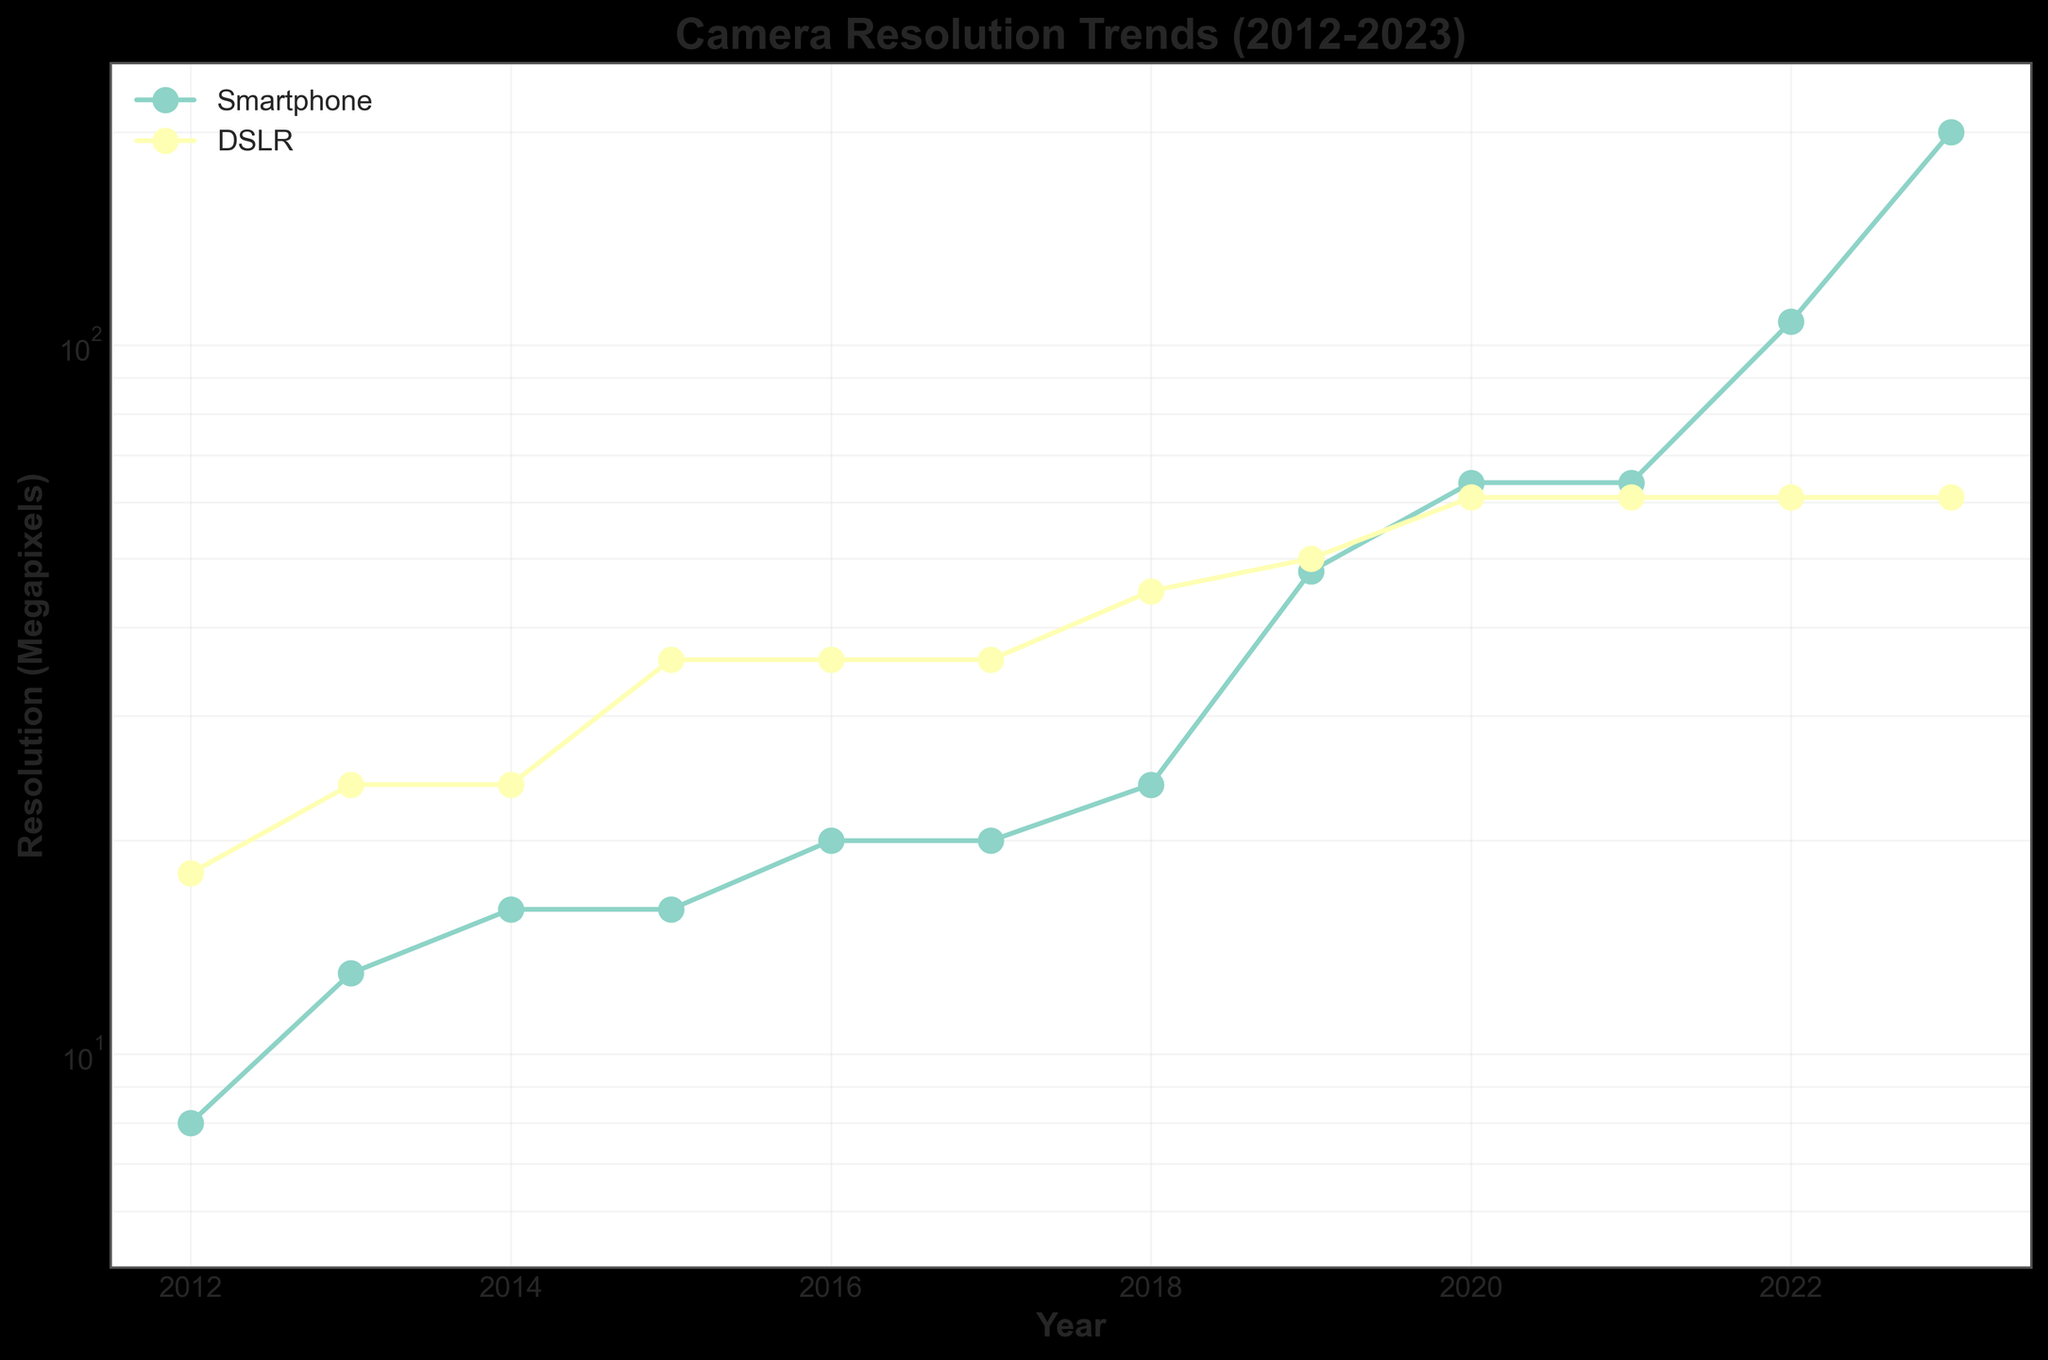What is the title of the figure? The title is displayed at the top of the figure in bold font.
Answer: Camera Resolution Trends (2012-2023) What are the devices compared in the figure? The legend in the upper left corner identifies the two device types with different labels and colors.
Answer: Smartphones and DSLRs How does the resolution of smartphones change from 2012 to 2023? Trace the points for the Smartphone line starting from 2012 to 2023, noting down the corresponding resolutions.
Answer: From 8 Megapixels to 200 Megapixels Which year shows the greatest increase in smartphone resolution? Look for the year where the gap between two consecutive points in the Smartphone line is the largest.
Answer: 2019 to 2020 What is the maximum resolution achieved by DSLRs over the years shown? Find the highest point on the DSLR line by looking at the y-axis values.
Answer: 61 Megapixels In which year did the resolution of smartphones first surpass 50 Megapixels? Identify the point at which the y-value for the Smartphone line exceeds 50 Megapixels by following from left to right.
Answer: 2019 Compare the resolution trends between smartphones and DSLRs over the decade. Observe the overall slopes and patterns of both lines. Note the continuous increase in smartphone resolution and the plateau in DSLR resolution.
Answer: Smartphones show a continuous increase, while DSLRs plateau around 61 Megapixels after 2019 What is the difference in resolution between smartphones and DSLRs in 2023? Locate the points for both devices in 2023, then subtract the DSLR resolution from the Smartphone resolution.
Answer: 200 - 61 = 139 Megapixels Calculate the average resolution of DSLRs from 2019 to 2023. Add the resolutions from 2019 to 2023 and divide by the number of years (50+61+61+61+61) / 5.
Answer: 58.8 Megapixels What trend does the log scale reveal about the rate of increase in smartphone resolution compared to a linear scale? The log scale shows exponential growth more clearly. Compare how consistent the increments look on a log scale to perceive a trend more accurately.
Answer: Exponential growth 